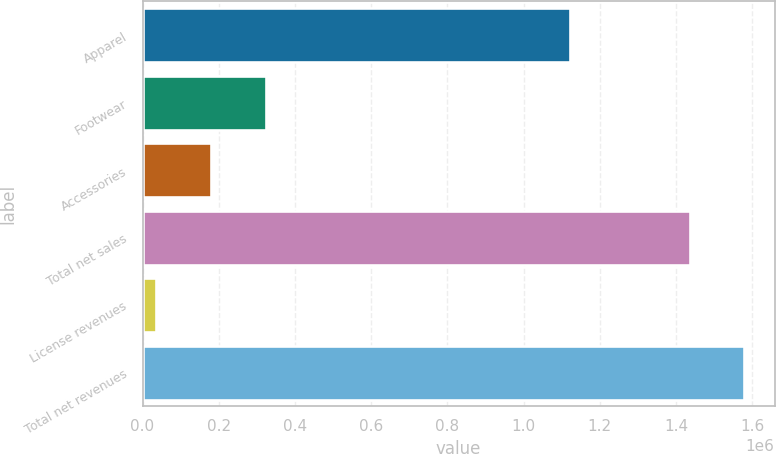<chart> <loc_0><loc_0><loc_500><loc_500><bar_chart><fcel>Apparel<fcel>Footwear<fcel>Accessories<fcel>Total net sales<fcel>License revenues<fcel>Total net revenues<nl><fcel>1.12203e+06<fcel>323792<fcel>180180<fcel>1.43612e+06<fcel>36569<fcel>1.57973e+06<nl></chart> 